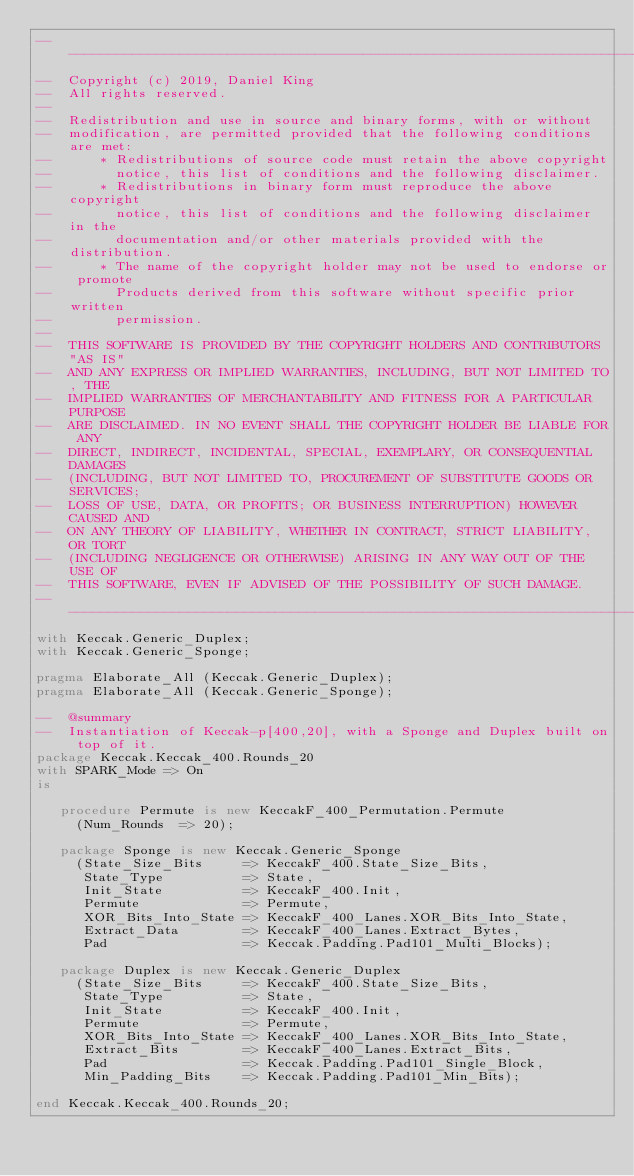Convert code to text. <code><loc_0><loc_0><loc_500><loc_500><_Ada_>-------------------------------------------------------------------------------
--  Copyright (c) 2019, Daniel King
--  All rights reserved.
--
--  Redistribution and use in source and binary forms, with or without
--  modification, are permitted provided that the following conditions are met:
--      * Redistributions of source code must retain the above copyright
--        notice, this list of conditions and the following disclaimer.
--      * Redistributions in binary form must reproduce the above copyright
--        notice, this list of conditions and the following disclaimer in the
--        documentation and/or other materials provided with the distribution.
--      * The name of the copyright holder may not be used to endorse or promote
--        Products derived from this software without specific prior written
--        permission.
--
--  THIS SOFTWARE IS PROVIDED BY THE COPYRIGHT HOLDERS AND CONTRIBUTORS "AS IS"
--  AND ANY EXPRESS OR IMPLIED WARRANTIES, INCLUDING, BUT NOT LIMITED TO, THE
--  IMPLIED WARRANTIES OF MERCHANTABILITY AND FITNESS FOR A PARTICULAR PURPOSE
--  ARE DISCLAIMED. IN NO EVENT SHALL THE COPYRIGHT HOLDER BE LIABLE FOR ANY
--  DIRECT, INDIRECT, INCIDENTAL, SPECIAL, EXEMPLARY, OR CONSEQUENTIAL DAMAGES
--  (INCLUDING, BUT NOT LIMITED TO, PROCUREMENT OF SUBSTITUTE GOODS OR SERVICES;
--  LOSS OF USE, DATA, OR PROFITS; OR BUSINESS INTERRUPTION) HOWEVER CAUSED AND
--  ON ANY THEORY OF LIABILITY, WHETHER IN CONTRACT, STRICT LIABILITY, OR TORT
--  (INCLUDING NEGLIGENCE OR OTHERWISE) ARISING IN ANY WAY OUT OF THE USE OF
--  THIS SOFTWARE, EVEN IF ADVISED OF THE POSSIBILITY OF SUCH DAMAGE.
-------------------------------------------------------------------------------
with Keccak.Generic_Duplex;
with Keccak.Generic_Sponge;

pragma Elaborate_All (Keccak.Generic_Duplex);
pragma Elaborate_All (Keccak.Generic_Sponge);

--  @summary
--  Instantiation of Keccak-p[400,20], with a Sponge and Duplex built on top of it.
package Keccak.Keccak_400.Rounds_20
with SPARK_Mode => On
is

   procedure Permute is new KeccakF_400_Permutation.Permute
     (Num_Rounds  => 20);

   package Sponge is new Keccak.Generic_Sponge
     (State_Size_Bits     => KeccakF_400.State_Size_Bits,
      State_Type          => State,
      Init_State          => KeccakF_400.Init,
      Permute             => Permute,
      XOR_Bits_Into_State => KeccakF_400_Lanes.XOR_Bits_Into_State,
      Extract_Data        => KeccakF_400_Lanes.Extract_Bytes,
      Pad                 => Keccak.Padding.Pad101_Multi_Blocks);

   package Duplex is new Keccak.Generic_Duplex
     (State_Size_Bits     => KeccakF_400.State_Size_Bits,
      State_Type          => State,
      Init_State          => KeccakF_400.Init,
      Permute             => Permute,
      XOR_Bits_Into_State => KeccakF_400_Lanes.XOR_Bits_Into_State,
      Extract_Bits        => KeccakF_400_Lanes.Extract_Bits,
      Pad                 => Keccak.Padding.Pad101_Single_Block,
      Min_Padding_Bits    => Keccak.Padding.Pad101_Min_Bits);

end Keccak.Keccak_400.Rounds_20;
</code> 